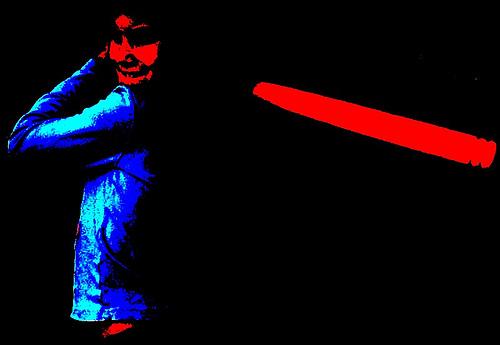What color is the bat?
Quick response, please. Red. Why is the person's coloring strange?
Concise answer only. It's glowing. Is the girl swinging a bat?
Concise answer only. Yes. Has this photo been processed?
Answer briefly. Yes. 